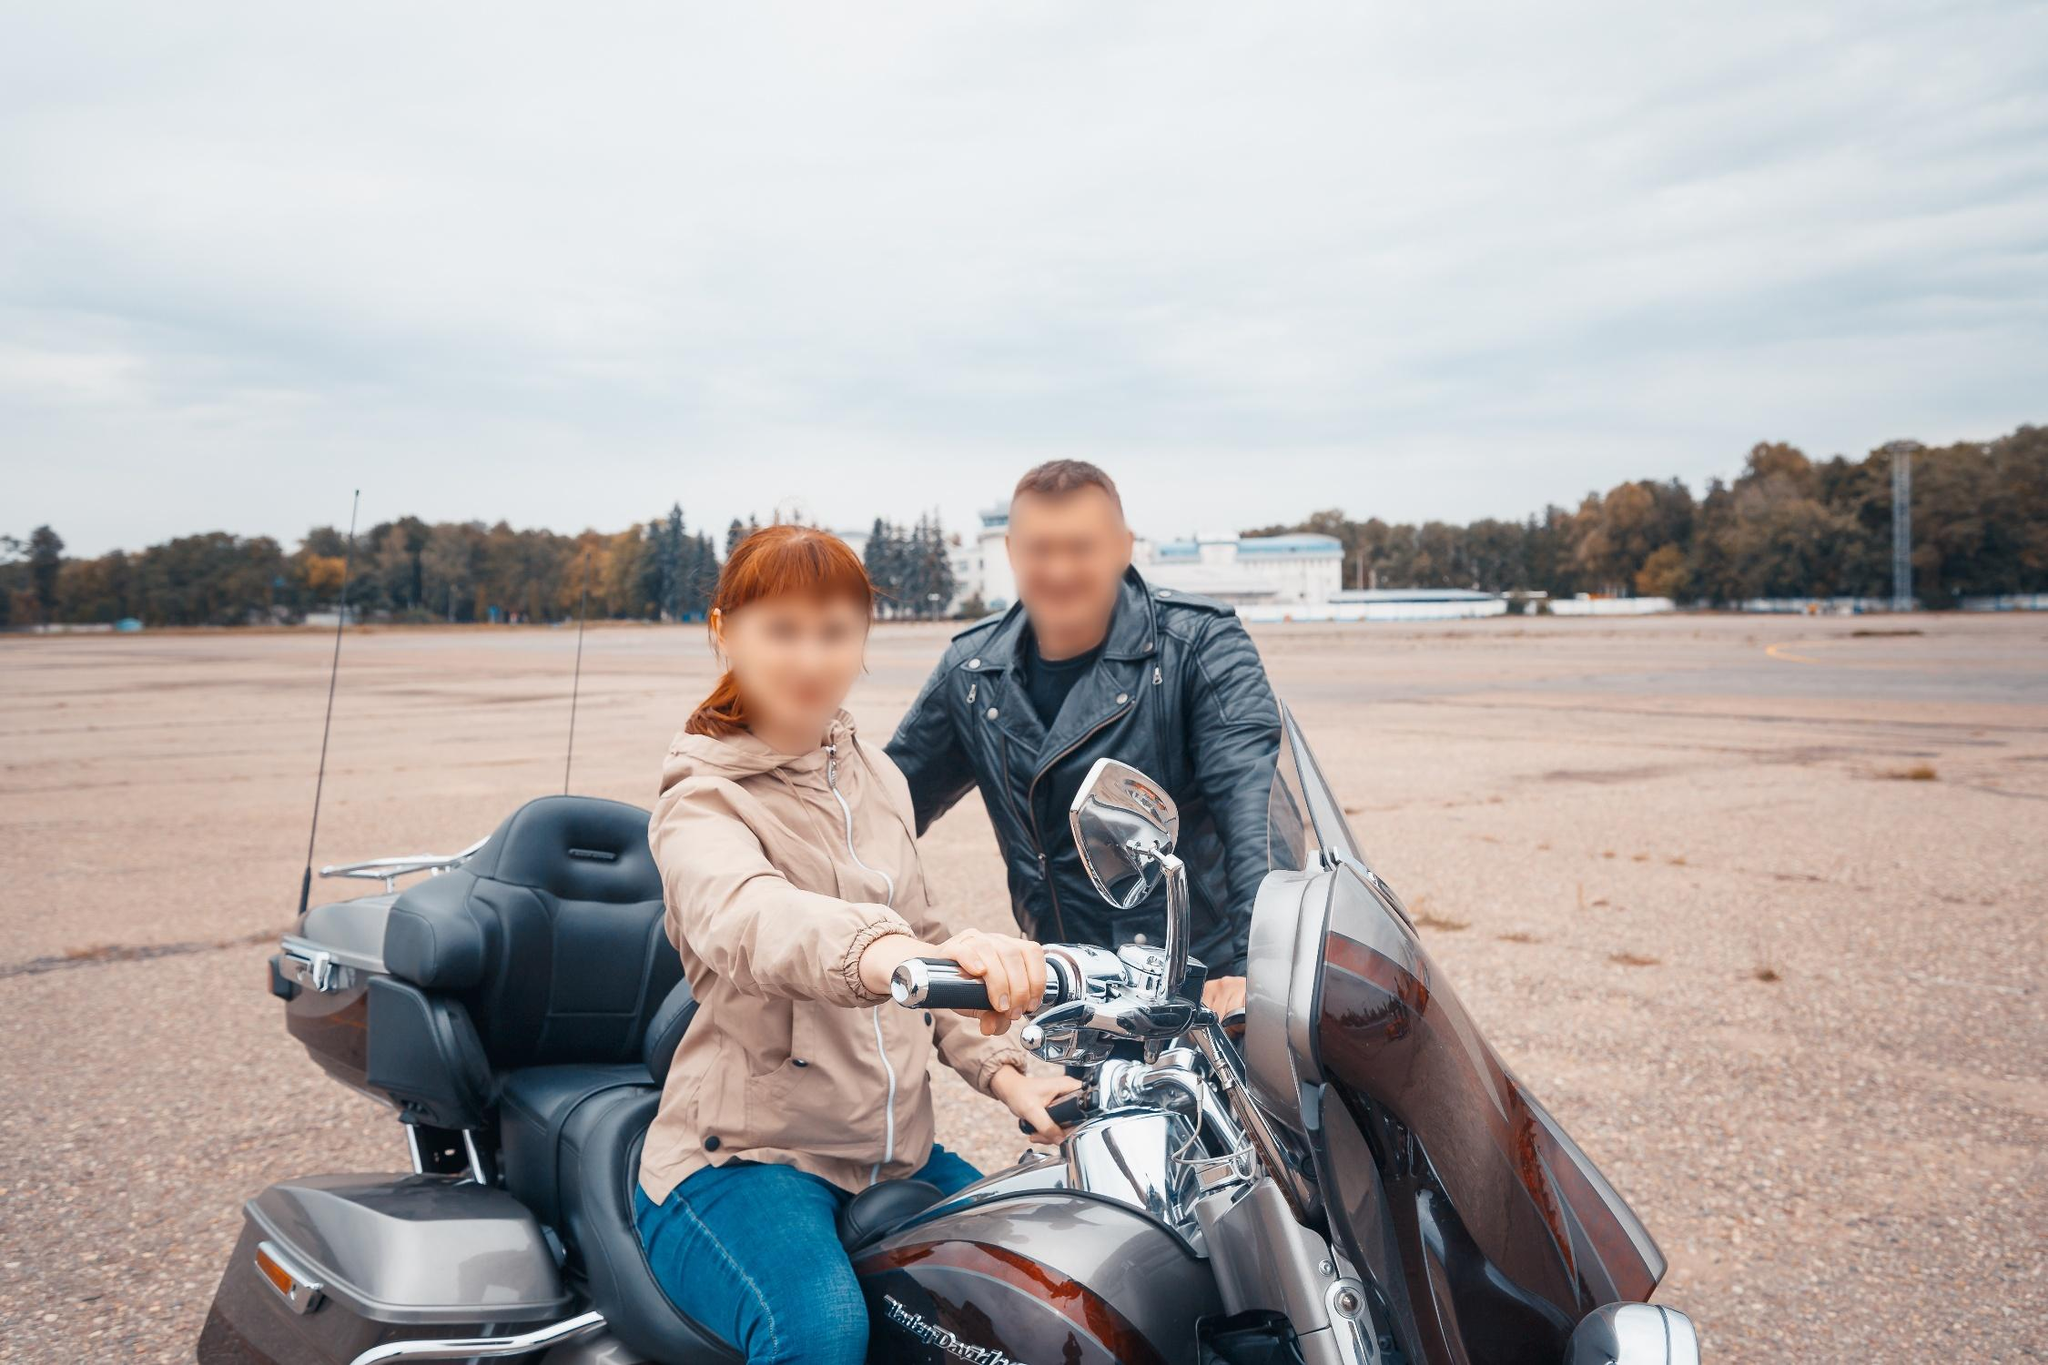If this image were part of a story, what would be the backstory of these two characters? In the story, the man and woman are lifelong friends who share a deep passion for adventure and motorcycles. Having grown up in a small town, they often dreamed of exploring the world beyond their hometown. The Harley Davidson motorcycle, a cherished possession they've been restoring together, symbolizes their shared aspirations and countless hours of teamwork. This particular day marks the beginning of their long-anticipated road trip across the country, a journey to rediscover themselves and their dreams. The overcast sky reflects their mixed emotions of excitement and the unknown as they ride towards new horizons and endless possibilities. The man and woman first met during a local motorbike rally, instantly bonding over their love for motorcycles. Through countless rides and adventures, they forged a bond that's as strong as the steel of their Harley Davidson. Now, after years of dreaming and saving, they've finally set off on a cross-country journey, leaving behind their everyday lives in search of freedom and endless highways. Their story is one of camaraderie, shared passion, and the pursuit of dreams on the open road. 